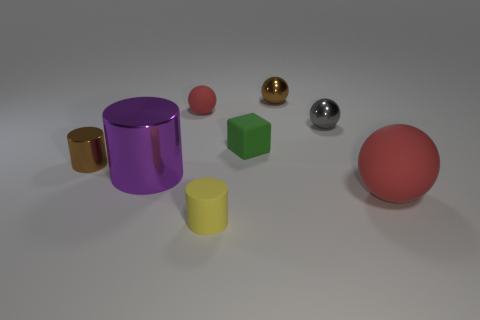Add 2 tiny red rubber balls. How many objects exist? 10 Subtract all cylinders. How many objects are left? 5 Add 2 red matte things. How many red matte things are left? 4 Add 6 big green cylinders. How many big green cylinders exist? 6 Subtract 1 red spheres. How many objects are left? 7 Subtract all tiny brown metallic balls. Subtract all purple metal cylinders. How many objects are left? 6 